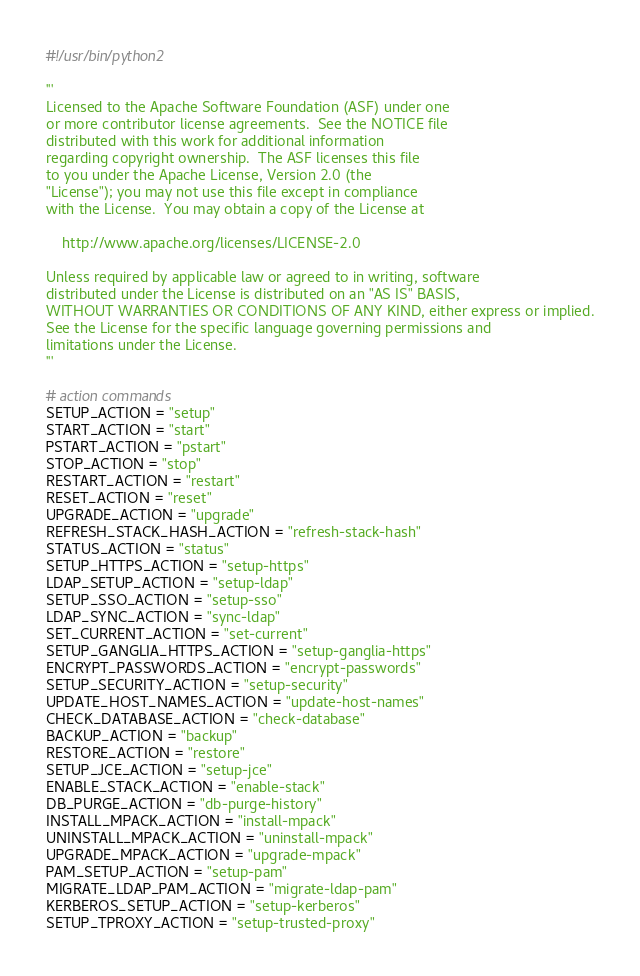<code> <loc_0><loc_0><loc_500><loc_500><_Python_>#!/usr/bin/python2

'''
Licensed to the Apache Software Foundation (ASF) under one
or more contributor license agreements.  See the NOTICE file
distributed with this work for additional information
regarding copyright ownership.  The ASF licenses this file
to you under the Apache License, Version 2.0 (the
"License"); you may not use this file except in compliance
with the License.  You may obtain a copy of the License at

    http://www.apache.org/licenses/LICENSE-2.0

Unless required by applicable law or agreed to in writing, software
distributed under the License is distributed on an "AS IS" BASIS,
WITHOUT WARRANTIES OR CONDITIONS OF ANY KIND, either express or implied.
See the License for the specific language governing permissions and
limitations under the License.
'''

# action commands
SETUP_ACTION = "setup"
START_ACTION = "start"
PSTART_ACTION = "pstart"
STOP_ACTION = "stop"
RESTART_ACTION = "restart"
RESET_ACTION = "reset"
UPGRADE_ACTION = "upgrade"
REFRESH_STACK_HASH_ACTION = "refresh-stack-hash"
STATUS_ACTION = "status"
SETUP_HTTPS_ACTION = "setup-https"
LDAP_SETUP_ACTION = "setup-ldap"
SETUP_SSO_ACTION = "setup-sso"
LDAP_SYNC_ACTION = "sync-ldap"
SET_CURRENT_ACTION = "set-current"
SETUP_GANGLIA_HTTPS_ACTION = "setup-ganglia-https"
ENCRYPT_PASSWORDS_ACTION = "encrypt-passwords"
SETUP_SECURITY_ACTION = "setup-security"
UPDATE_HOST_NAMES_ACTION = "update-host-names"
CHECK_DATABASE_ACTION = "check-database"
BACKUP_ACTION = "backup"
RESTORE_ACTION = "restore"
SETUP_JCE_ACTION = "setup-jce"
ENABLE_STACK_ACTION = "enable-stack"
DB_PURGE_ACTION = "db-purge-history"
INSTALL_MPACK_ACTION = "install-mpack"
UNINSTALL_MPACK_ACTION = "uninstall-mpack"
UPGRADE_MPACK_ACTION = "upgrade-mpack"
PAM_SETUP_ACTION = "setup-pam"
MIGRATE_LDAP_PAM_ACTION = "migrate-ldap-pam"
KERBEROS_SETUP_ACTION = "setup-kerberos"
SETUP_TPROXY_ACTION = "setup-trusted-proxy"
</code> 